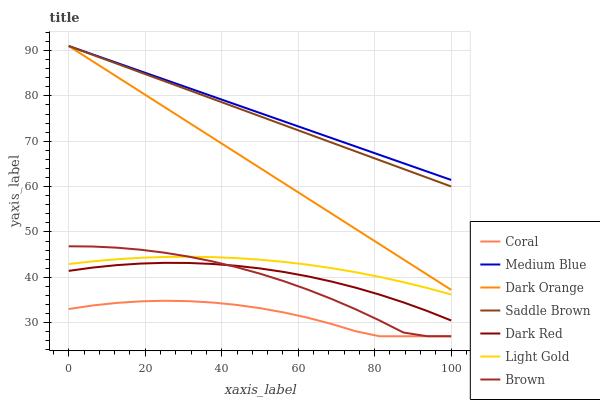Does Brown have the minimum area under the curve?
Answer yes or no. No. Does Brown have the maximum area under the curve?
Answer yes or no. No. Is Dark Red the smoothest?
Answer yes or no. No. Is Dark Red the roughest?
Answer yes or no. No. Does Dark Red have the lowest value?
Answer yes or no. No. Does Brown have the highest value?
Answer yes or no. No. Is Coral less than Dark Orange?
Answer yes or no. Yes. Is Dark Orange greater than Dark Red?
Answer yes or no. Yes. Does Coral intersect Dark Orange?
Answer yes or no. No. 